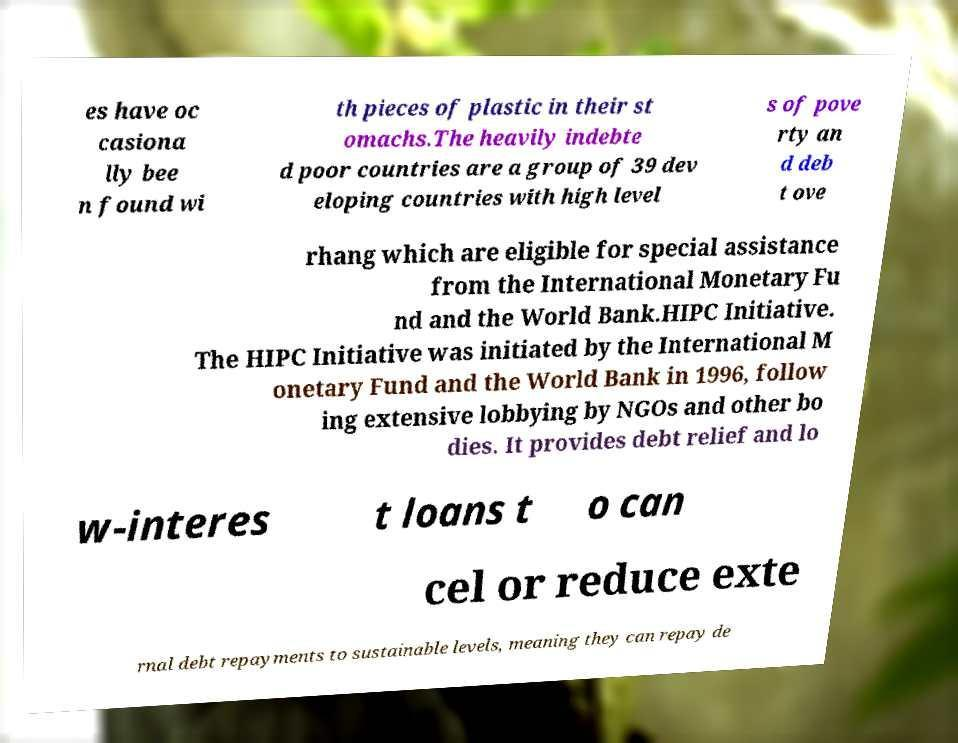Can you read and provide the text displayed in the image?This photo seems to have some interesting text. Can you extract and type it out for me? es have oc casiona lly bee n found wi th pieces of plastic in their st omachs.The heavily indebte d poor countries are a group of 39 dev eloping countries with high level s of pove rty an d deb t ove rhang which are eligible for special assistance from the International Monetary Fu nd and the World Bank.HIPC Initiative. The HIPC Initiative was initiated by the International M onetary Fund and the World Bank in 1996, follow ing extensive lobbying by NGOs and other bo dies. It provides debt relief and lo w-interes t loans t o can cel or reduce exte rnal debt repayments to sustainable levels, meaning they can repay de 